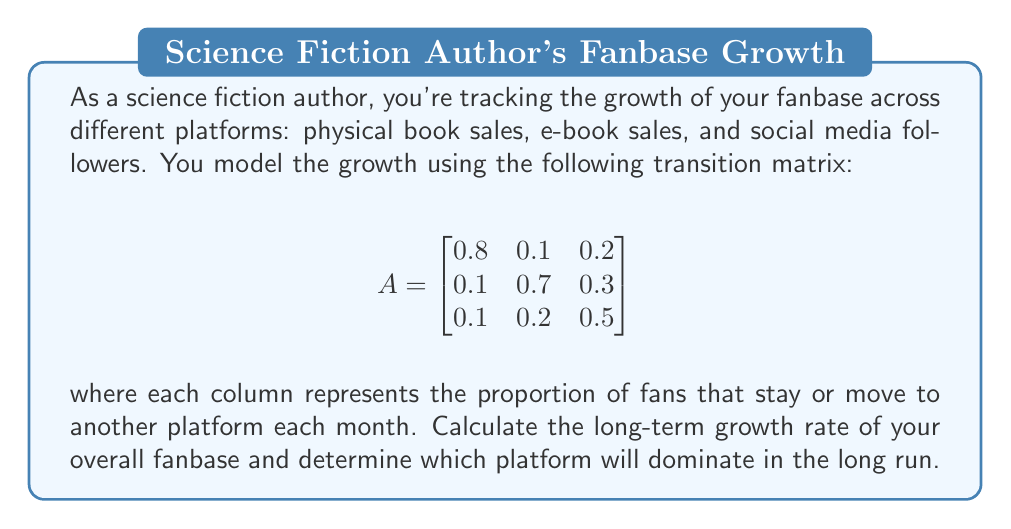Can you solve this math problem? To solve this problem, we need to find the eigenvalues and eigenvectors of the transition matrix A. The dominant eigenvalue will give us the long-term growth rate, and its corresponding eigenvector will show the relative distribution of fans across platforms.

1. Find the characteristic equation:
   $det(A - \lambda I) = 0$
   
   $$\begin{vmatrix}
   0.8-\lambda & 0.1 & 0.2 \\
   0.1 & 0.7-\lambda & 0.3 \\
   0.1 & 0.2 & 0.5-\lambda
   \end{vmatrix} = 0$$

2. Expand the determinant:
   $-\lambda^3 + 2\lambda^2 - 1.09\lambda + 0.19 = 0$

3. Solve for eigenvalues. The solutions are:
   $\lambda_1 = 1$, $\lambda_2 \approx 0.7$, $\lambda_3 \approx 0.3$

4. The dominant eigenvalue is $\lambda_1 = 1$, which means the overall fanbase size will stabilize in the long run (neither growing nor shrinking).

5. Find the eigenvector $v_1$ corresponding to $\lambda_1 = 1$:
   $(A - I)v_1 = 0$

   $$\begin{bmatrix}
   -0.2 & 0.1 & 0.2 \\
   0.1 & -0.3 & 0.3 \\
   0.1 & 0.2 & -0.5
   \end{bmatrix}\begin{bmatrix}
   v_1 \\ v_2 \\ v_3
   \end{bmatrix} = \begin{bmatrix}
   0 \\ 0 \\ 0
   \end{bmatrix}$$

6. Solve this system to get:
   $v_1 = \begin{bmatrix}
   0.4 \\ 0.4 \\ 0.2
   \end{bmatrix}$

7. Normalize the eigenvector so its components sum to 1:
   $v_1 = \begin{bmatrix}
   0.4 \\ 0.4 \\ 0.2
   \end{bmatrix}$

This normalized eigenvector represents the long-term distribution of fans across the three platforms.
Answer: The long-term growth rate of the overall fanbase is 1 (stable), and the distribution of fans will converge to 40% physical book readers, 40% e-book readers, and 20% social media followers. Physical books and e-books will jointly dominate in the long run, each with 40% of the fanbase. 